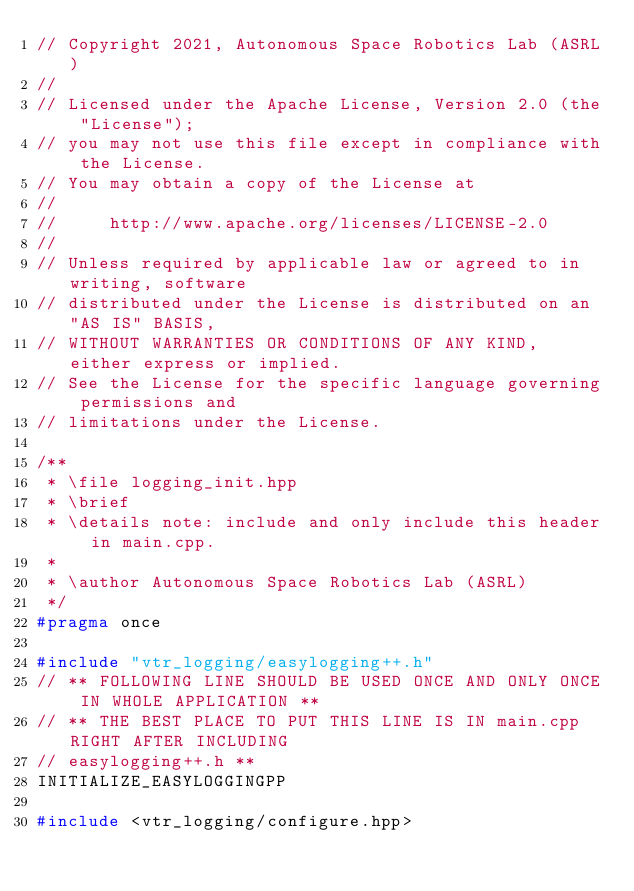Convert code to text. <code><loc_0><loc_0><loc_500><loc_500><_C++_>// Copyright 2021, Autonomous Space Robotics Lab (ASRL)
//
// Licensed under the Apache License, Version 2.0 (the "License");
// you may not use this file except in compliance with the License.
// You may obtain a copy of the License at
//
//     http://www.apache.org/licenses/LICENSE-2.0
//
// Unless required by applicable law or agreed to in writing, software
// distributed under the License is distributed on an "AS IS" BASIS,
// WITHOUT WARRANTIES OR CONDITIONS OF ANY KIND, either express or implied.
// See the License for the specific language governing permissions and
// limitations under the License.

/**
 * \file logging_init.hpp
 * \brief
 * \details note: include and only include this header in main.cpp.
 *
 * \author Autonomous Space Robotics Lab (ASRL)
 */
#pragma once

#include "vtr_logging/easylogging++.h"
// ** FOLLOWING LINE SHOULD BE USED ONCE AND ONLY ONCE IN WHOLE APPLICATION **
// ** THE BEST PLACE TO PUT THIS LINE IS IN main.cpp RIGHT AFTER INCLUDING
// easylogging++.h **
INITIALIZE_EASYLOGGINGPP

#include <vtr_logging/configure.hpp></code> 